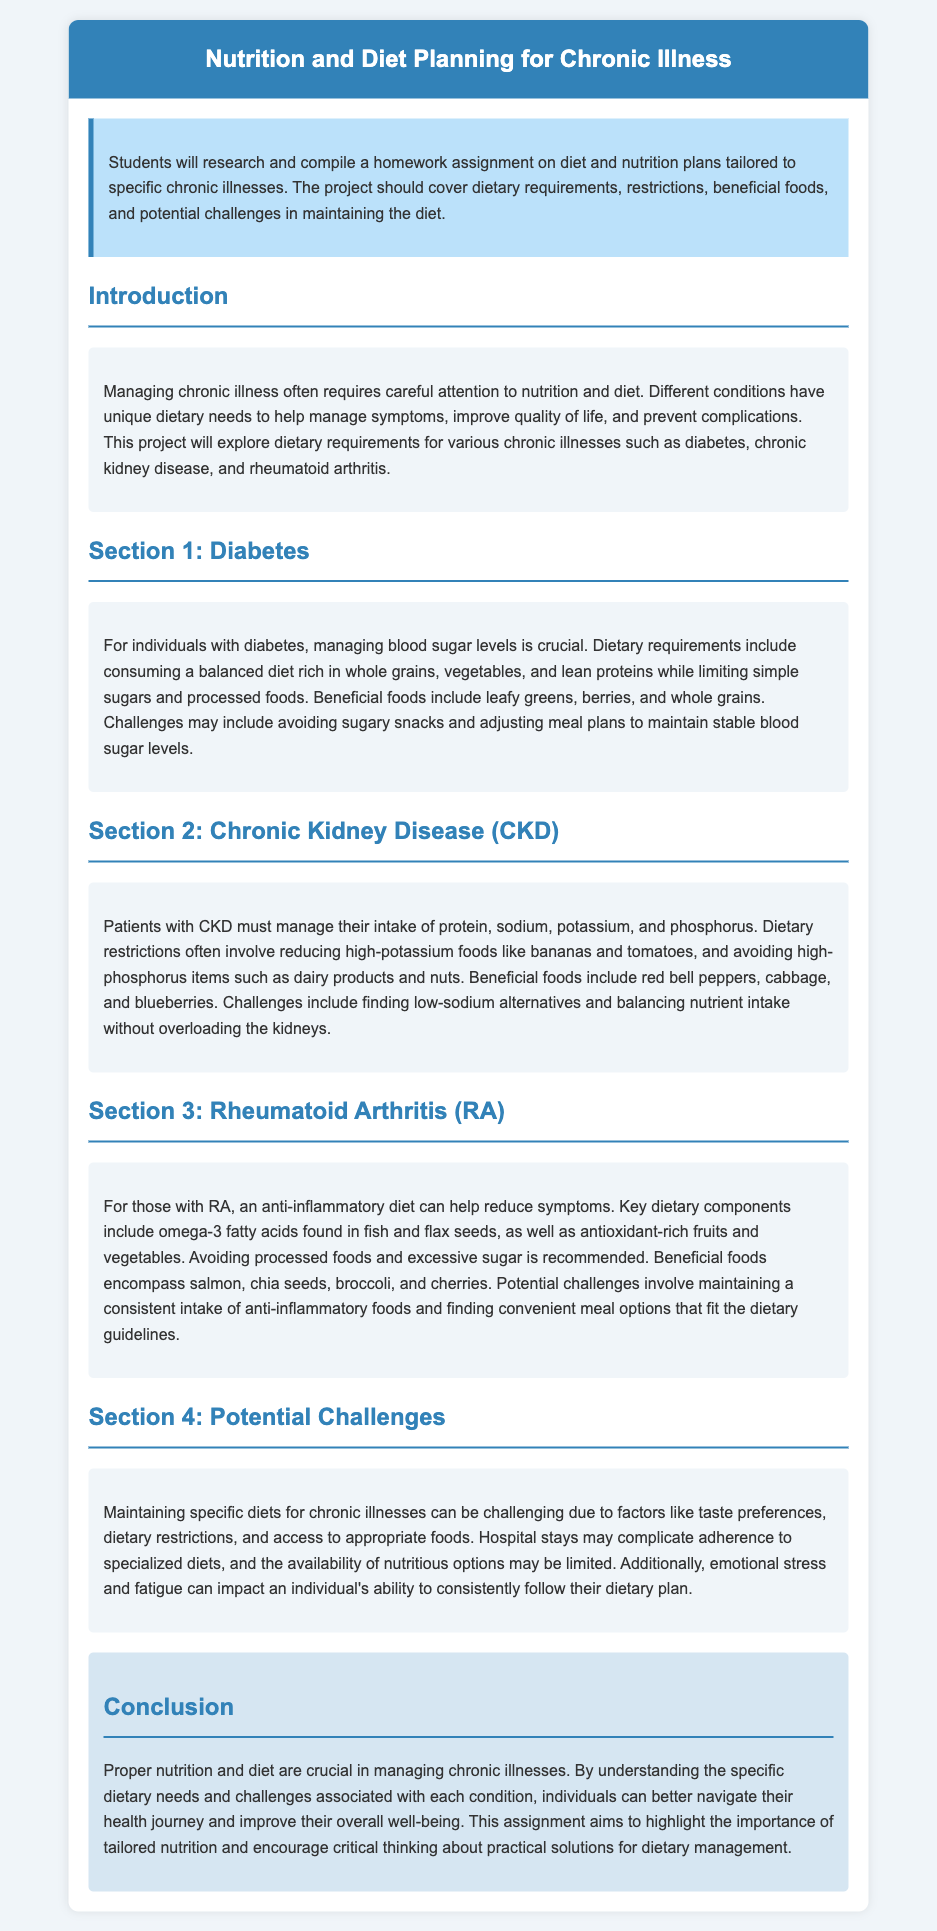What is the title of the homework assignment? The title can be found in the header of the document.
Answer: Nutrition and Diet Planning for Chronic Illness What are the three chronic illnesses discussed? The specific illnesses are listed under their respective sections in the document.
Answer: Diabetes, Chronic Kidney Disease, Rheumatoid Arthritis What is a beneficial food for diabetes? This information can be found in the section discussing dietary requirements for diabetes.
Answer: Leafy greens What dietary restriction do patients with Chronic Kidney Disease need to manage? The document provides specific dietary restrictions listed in the CKD section.
Answer: Sodium What type of diet is recommended for Rheumatoid Arthritis? The document provides a clear description of the dietary approach for RA.
Answer: Anti-inflammatory diet What are two potential challenges in maintaining diets for chronic illnesses? These challenges are discussed in the section dedicated to potential challenges in diet maintenance.
Answer: Taste preferences, limited access How does nutrition impact chronic illness management? This information is summarized in the conclusion of the document.
Answer: Crucial What foods should be avoided for Chronic Kidney Disease? The document specifies foods to avoid in the CKD section.
Answer: High-potassium foods What is the importance of tailored nutrition as highlighted in the document? The conclusion emphasizes the significance of personalized dietary management.
Answer: Improve overall well-being 